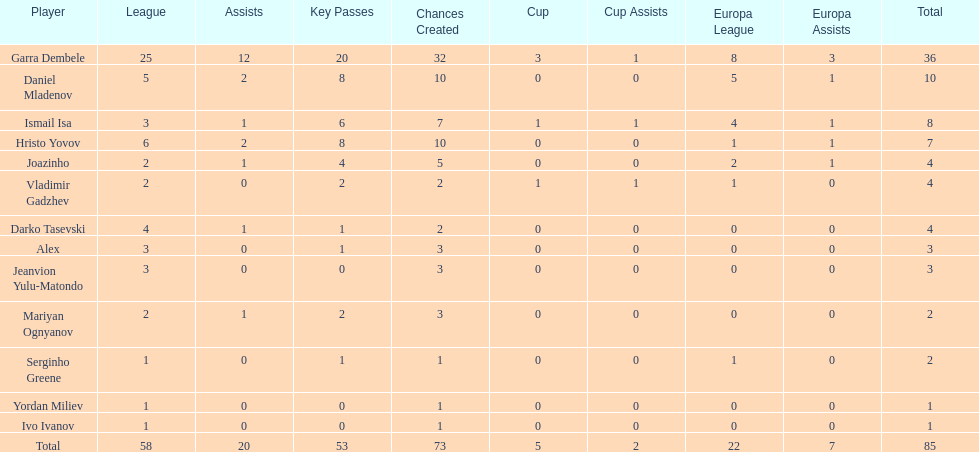How many of the players did not score any goals in the cup? 10. 